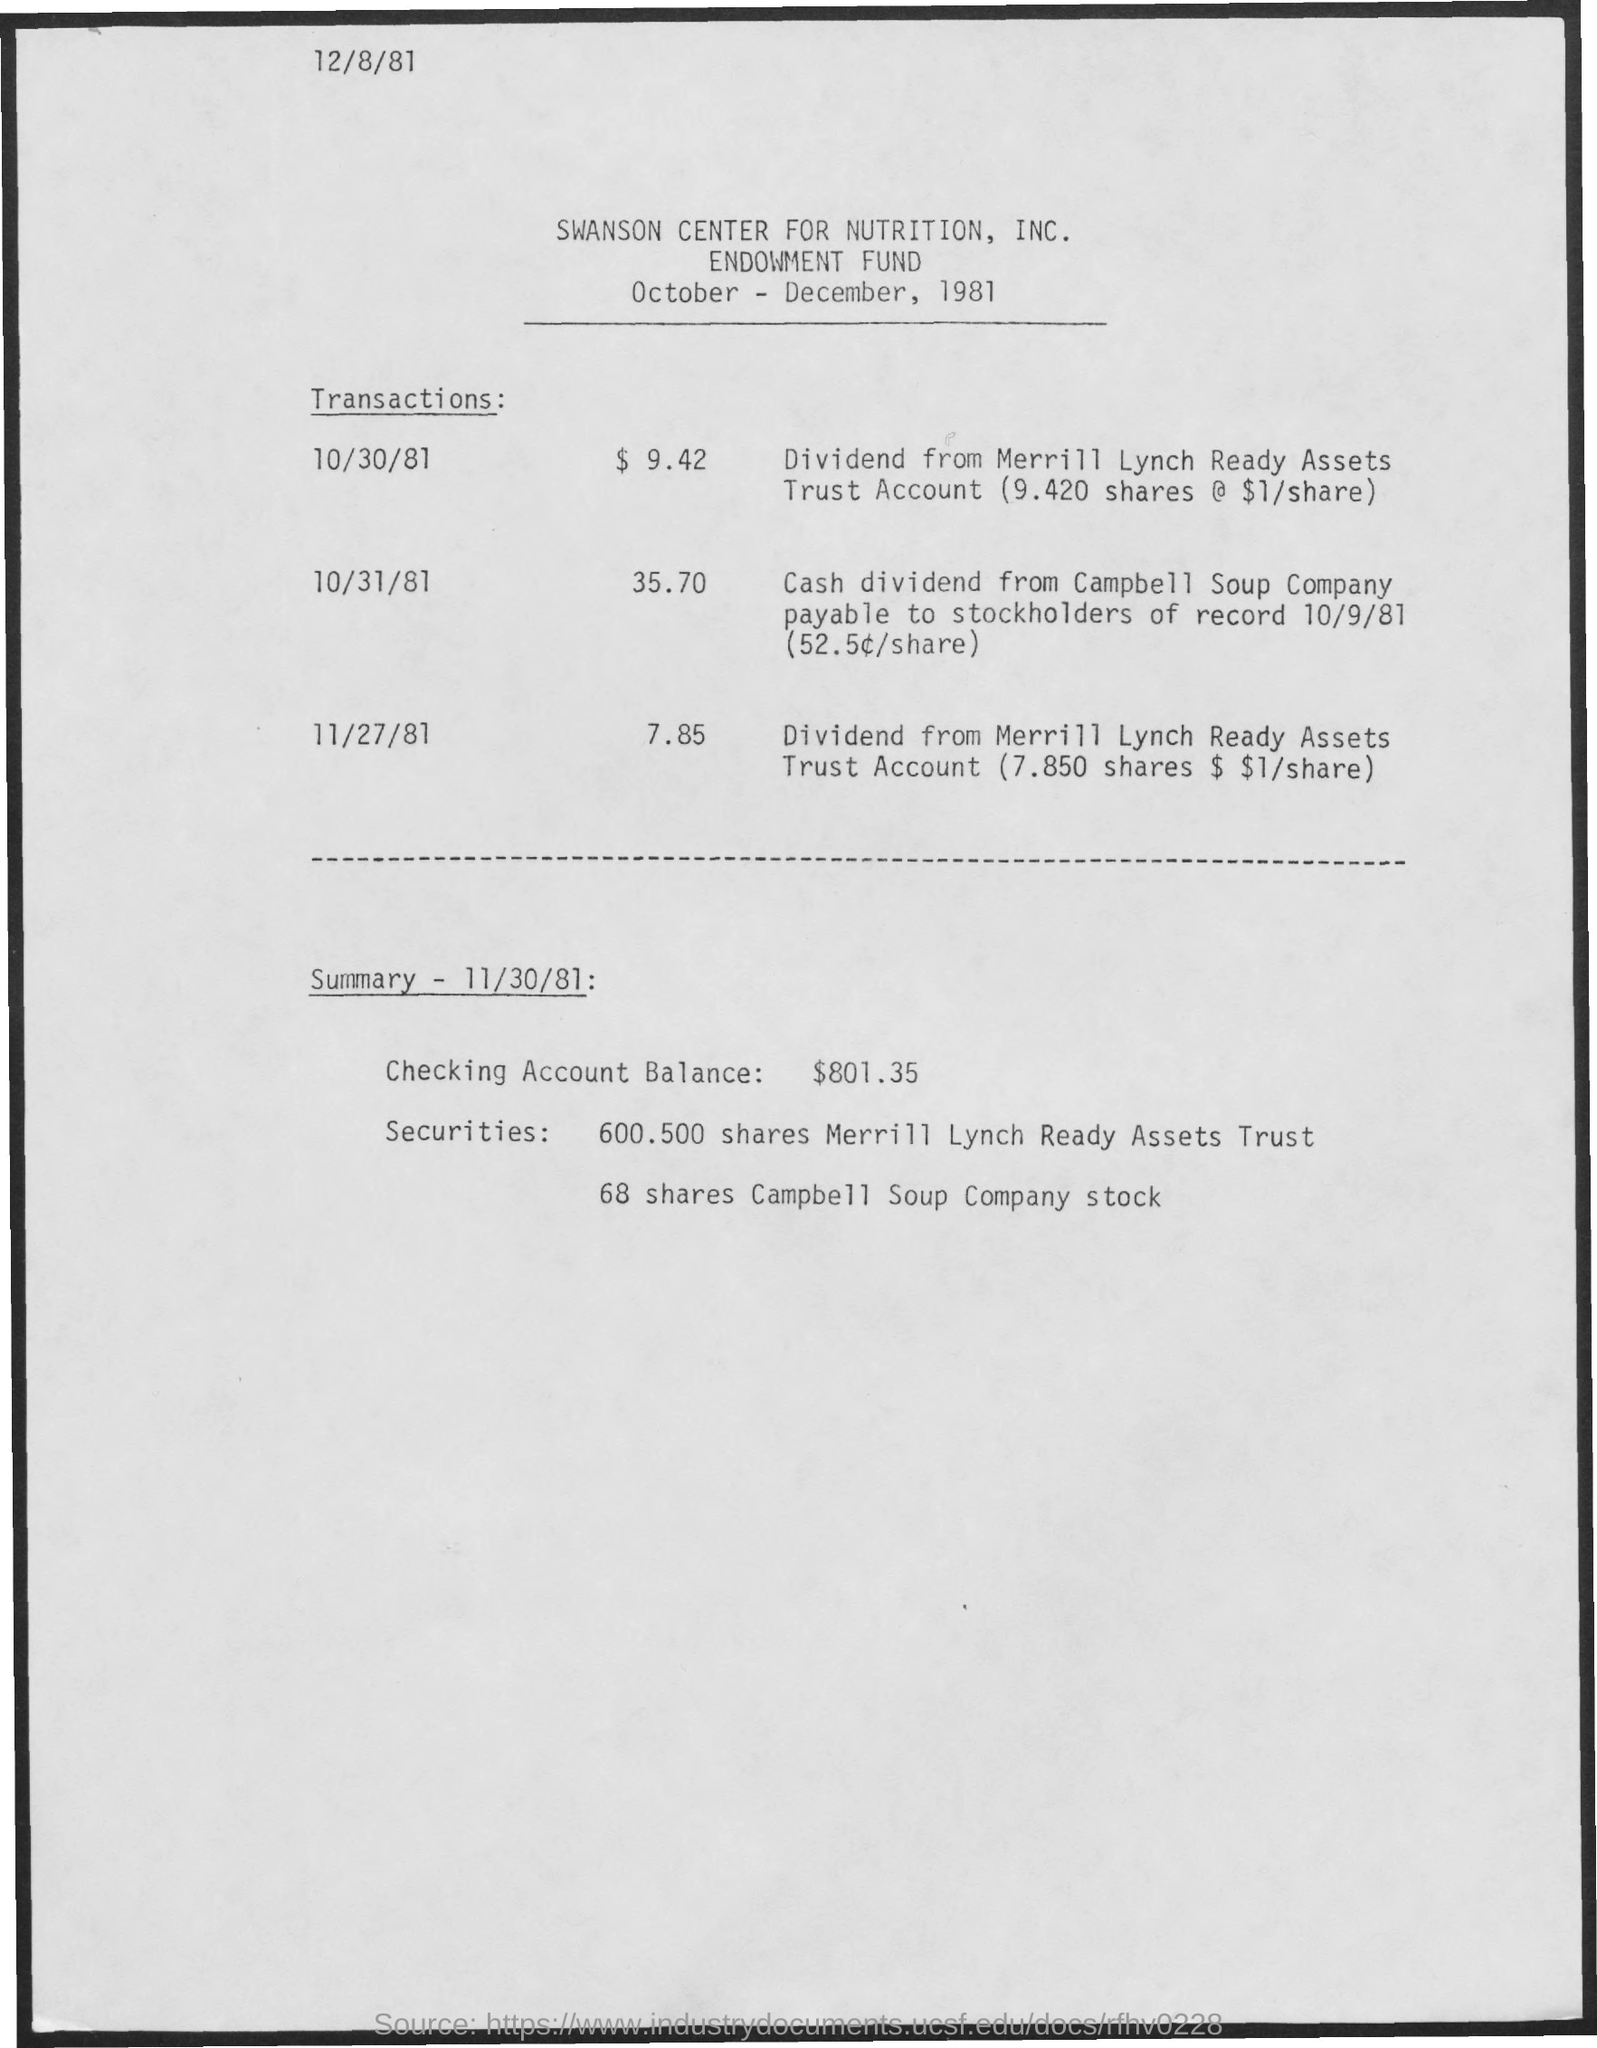Give some essential details in this illustration. The securities for Merrill Lynch Ready Assets Trust are 600.500 shares. On November 27th, 1981, the transaction amount was 7.85. The Campbell Soup Company stock has securities for 68 shares. On October 30th, 1981, the transaction amount was $9.42. The transaction amount for 10/31/81 was 35.70. 